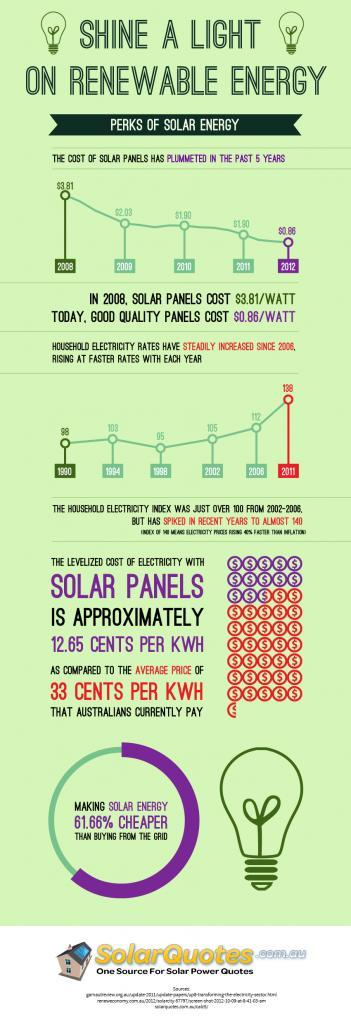In how many years the household electricity index is greater than 110?
Answer the question with a short phrase. 2 In how many years the household electricity index greater than 100? 4 What is the difference between solar panel costs in 2008 and 2009? $1.78 What is the difference between solar panel costs in 2009 and 2010? $0.13 In which all years solar panel cost is the same? 2010, 2011 